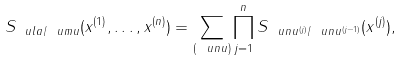Convert formula to latex. <formula><loc_0><loc_0><loc_500><loc_500>S _ { \ u l a / \ u m u } ( x ^ { ( 1 ) } , \dots , x ^ { ( n ) } ) = \sum _ { ( \ u n u ) } \prod _ { j = 1 } ^ { n } S _ { \ u n u ^ { ( j ) } / \ u n u ^ { ( j - 1 ) } } ( x ^ { ( j ) } ) ,</formula> 